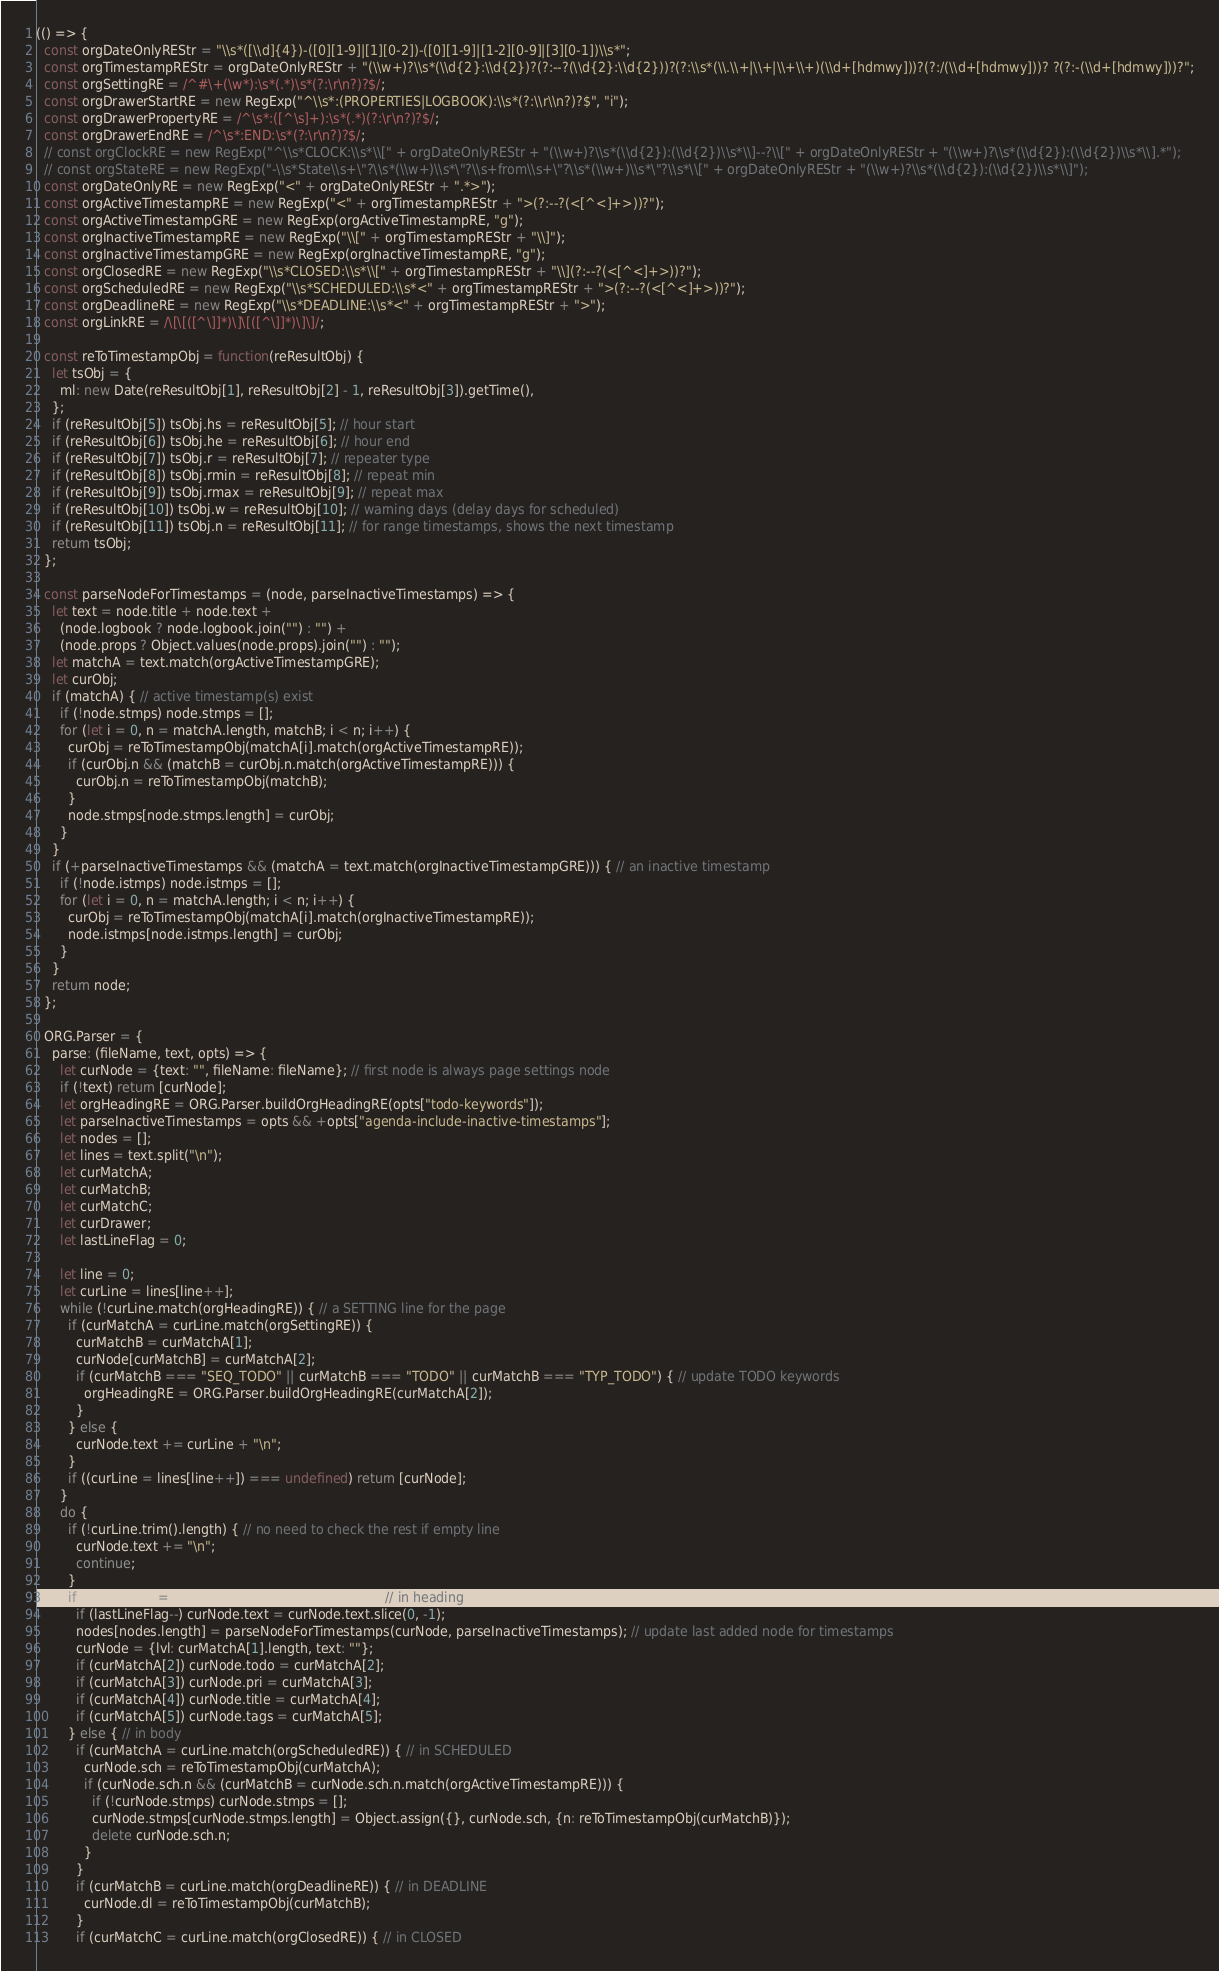Convert code to text. <code><loc_0><loc_0><loc_500><loc_500><_JavaScript_>(() => {
  const orgDateOnlyREStr = "\\s*([\\d]{4})-([0][1-9]|[1][0-2])-([0][1-9]|[1-2][0-9]|[3][0-1])\\s*";
  const orgTimestampREStr = orgDateOnlyREStr + "(\\w+)?\\s*(\\d{2}:\\d{2})?(?:--?(\\d{2}:\\d{2}))?(?:\\s*(\\.\\+|\\+|\\+\\+)(\\d+[hdmwy]))?(?:/(\\d+[hdmwy]))? ?(?:-(\\d+[hdmwy]))?";
  const orgSettingRE = /^#\+(\w*):\s*(.*)\s*(?:\r\n?)?$/;
  const orgDrawerStartRE = new RegExp("^\\s*:(PROPERTIES|LOGBOOK):\\s*(?:\\r\\n?)?$", "i");
  const orgDrawerPropertyRE = /^\s*:([^\s]+):\s*(.*)(?:\r\n?)?$/;
  const orgDrawerEndRE = /^\s*:END:\s*(?:\r\n?)?$/;
  // const orgClockRE = new RegExp("^\\s*CLOCK:\\s*\\[" + orgDateOnlyREStr + "(\\w+)?\\s*(\\d{2}):(\\d{2})\\s*\\]--?\\[" + orgDateOnlyREStr + "(\\w+)?\\s*(\\d{2}):(\\d{2})\\s*\\].*");
  // const orgStateRE = new RegExp("-\\s*State\\s+\"?\\s*(\\w+)\\s*\"?\\s+from\\s+\"?\\s*(\\w+)\\s*\"?\\s*\\[" + orgDateOnlyREStr + "(\\w+)?\\s*(\\d{2}):(\\d{2})\\s*\\]");
  const orgDateOnlyRE = new RegExp("<" + orgDateOnlyREStr + ".*>");
  const orgActiveTimestampRE = new RegExp("<" + orgTimestampREStr + ">(?:--?(<[^<]+>))?");
  const orgActiveTimestampGRE = new RegExp(orgActiveTimestampRE, "g");
  const orgInactiveTimestampRE = new RegExp("\\[" + orgTimestampREStr + "\\]");
  const orgInactiveTimestampGRE = new RegExp(orgInactiveTimestampRE, "g");
  const orgClosedRE = new RegExp("\\s*CLOSED:\\s*\\[" + orgTimestampREStr + "\\](?:--?(<[^<]+>))?");
  const orgScheduledRE = new RegExp("\\s*SCHEDULED:\\s*<" + orgTimestampREStr + ">(?:--?(<[^<]+>))?");
  const orgDeadlineRE = new RegExp("\\s*DEADLINE:\\s*<" + orgTimestampREStr + ">");
  const orgLinkRE = /\[\[([^\]]*)\]\[([^\]]*)\]\]/;

  const reToTimestampObj = function(reResultObj) {
    let tsObj = {
      ml: new Date(reResultObj[1], reResultObj[2] - 1, reResultObj[3]).getTime(),
    };
    if (reResultObj[5]) tsObj.hs = reResultObj[5]; // hour start
    if (reResultObj[6]) tsObj.he = reResultObj[6]; // hour end
    if (reResultObj[7]) tsObj.r = reResultObj[7]; // repeater type
    if (reResultObj[8]) tsObj.rmin = reResultObj[8]; // repeat min
    if (reResultObj[9]) tsObj.rmax = reResultObj[9]; // repeat max
    if (reResultObj[10]) tsObj.w = reResultObj[10]; // warning days (delay days for scheduled)
    if (reResultObj[11]) tsObj.n = reResultObj[11]; // for range timestamps, shows the next timestamp
    return tsObj;
  };

  const parseNodeForTimestamps = (node, parseInactiveTimestamps) => {
    let text = node.title + node.text +
      (node.logbook ? node.logbook.join("") : "") +
      (node.props ? Object.values(node.props).join("") : "");
    let matchA = text.match(orgActiveTimestampGRE);
    let curObj;
    if (matchA) { // active timestamp(s) exist
      if (!node.stmps) node.stmps = [];
      for (let i = 0, n = matchA.length, matchB; i < n; i++) {
        curObj = reToTimestampObj(matchA[i].match(orgActiveTimestampRE));
        if (curObj.n && (matchB = curObj.n.match(orgActiveTimestampRE))) {
          curObj.n = reToTimestampObj(matchB);
        }
        node.stmps[node.stmps.length] = curObj;
      }
    }
    if (+parseInactiveTimestamps && (matchA = text.match(orgInactiveTimestampGRE))) { // an inactive timestamp
      if (!node.istmps) node.istmps = [];
      for (let i = 0, n = matchA.length; i < n; i++) {
        curObj = reToTimestampObj(matchA[i].match(orgInactiveTimestampRE));
        node.istmps[node.istmps.length] = curObj;
      }
    }
    return node;
  };

  ORG.Parser = {
    parse: (fileName, text, opts) => {
      let curNode = {text: "", fileName: fileName}; // first node is always page settings node
      if (!text) return [curNode];
      let orgHeadingRE = ORG.Parser.buildOrgHeadingRE(opts["todo-keywords"]);
      let parseInactiveTimestamps = opts && +opts["agenda-include-inactive-timestamps"];
      let nodes = [];
      let lines = text.split("\n");
      let curMatchA;
      let curMatchB;
      let curMatchC;
      let curDrawer;
      let lastLineFlag = 0;

      let line = 0;
      let curLine = lines[line++];
      while (!curLine.match(orgHeadingRE)) { // a SETTING line for the page
        if (curMatchA = curLine.match(orgSettingRE)) {
          curMatchB = curMatchA[1];
          curNode[curMatchB] = curMatchA[2];
          if (curMatchB === "SEQ_TODO" || curMatchB === "TODO" || curMatchB === "TYP_TODO") { // update TODO keywords
            orgHeadingRE = ORG.Parser.buildOrgHeadingRE(curMatchA[2]);
          }
        } else {
          curNode.text += curLine + "\n";
        }
        if ((curLine = lines[line++]) === undefined) return [curNode];
      }
      do {
        if (!curLine.trim().length) { // no need to check the rest if empty line
          curNode.text += "\n";
          continue;
        }
        if (curMatchA = curLine.match(orgHeadingRE)) { // in heading
          if (lastLineFlag--) curNode.text = curNode.text.slice(0, -1);
          nodes[nodes.length] = parseNodeForTimestamps(curNode, parseInactiveTimestamps); // update last added node for timestamps
          curNode = {lvl: curMatchA[1].length, text: ""};
          if (curMatchA[2]) curNode.todo = curMatchA[2];
          if (curMatchA[3]) curNode.pri = curMatchA[3];
          if (curMatchA[4]) curNode.title = curMatchA[4];
          if (curMatchA[5]) curNode.tags = curMatchA[5];
        } else { // in body
          if (curMatchA = curLine.match(orgScheduledRE)) { // in SCHEDULED
            curNode.sch = reToTimestampObj(curMatchA);
            if (curNode.sch.n && (curMatchB = curNode.sch.n.match(orgActiveTimestampRE))) {
              if (!curNode.stmps) curNode.stmps = [];
              curNode.stmps[curNode.stmps.length] = Object.assign({}, curNode.sch, {n: reToTimestampObj(curMatchB)});
              delete curNode.sch.n;
            }
          }
          if (curMatchB = curLine.match(orgDeadlineRE)) { // in DEADLINE
            curNode.dl = reToTimestampObj(curMatchB);
          }
          if (curMatchC = curLine.match(orgClosedRE)) { // in CLOSED</code> 